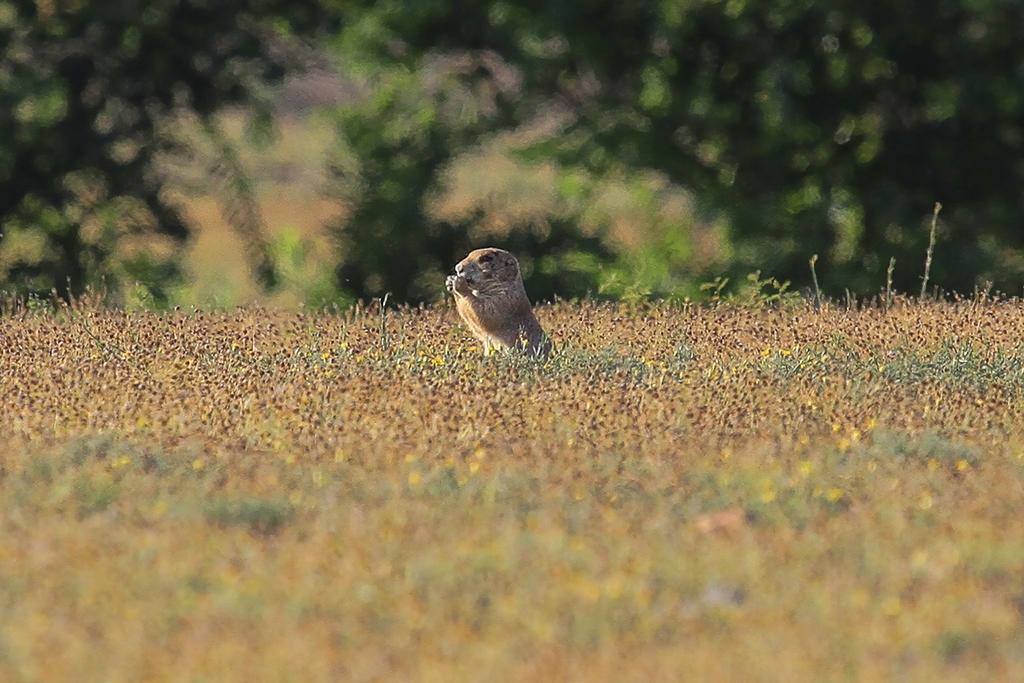In one or two sentences, can you explain what this image depicts? In the image we can see an animal, grass, trees and the background is blurred. 